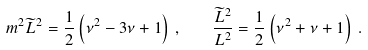Convert formula to latex. <formula><loc_0><loc_0><loc_500><loc_500>m ^ { 2 } \widetilde { L } ^ { 2 } = \frac { 1 } { 2 } \left ( \nu ^ { 2 } - 3 \nu + 1 \right ) \, , \quad \frac { \widetilde { L } ^ { 2 } } { L ^ { 2 } } = \frac { 1 } { 2 } \left ( \nu ^ { 2 } + \nu + 1 \right ) \, .</formula> 